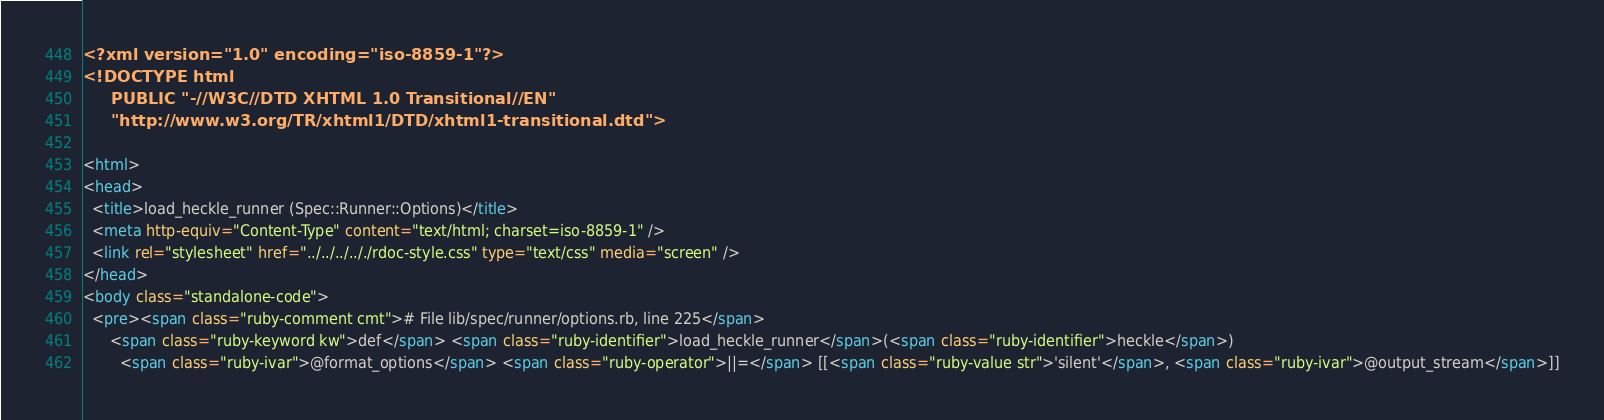Convert code to text. <code><loc_0><loc_0><loc_500><loc_500><_HTML_><?xml version="1.0" encoding="iso-8859-1"?>
<!DOCTYPE html 
     PUBLIC "-//W3C//DTD XHTML 1.0 Transitional//EN"
     "http://www.w3.org/TR/xhtml1/DTD/xhtml1-transitional.dtd">

<html>
<head>
  <title>load_heckle_runner (Spec::Runner::Options)</title>
  <meta http-equiv="Content-Type" content="text/html; charset=iso-8859-1" />
  <link rel="stylesheet" href="../../../.././rdoc-style.css" type="text/css" media="screen" />
</head>
<body class="standalone-code">
  <pre><span class="ruby-comment cmt"># File lib/spec/runner/options.rb, line 225</span>
      <span class="ruby-keyword kw">def</span> <span class="ruby-identifier">load_heckle_runner</span>(<span class="ruby-identifier">heckle</span>)
        <span class="ruby-ivar">@format_options</span> <span class="ruby-operator">||=</span> [[<span class="ruby-value str">'silent'</span>, <span class="ruby-ivar">@output_stream</span>]]</code> 